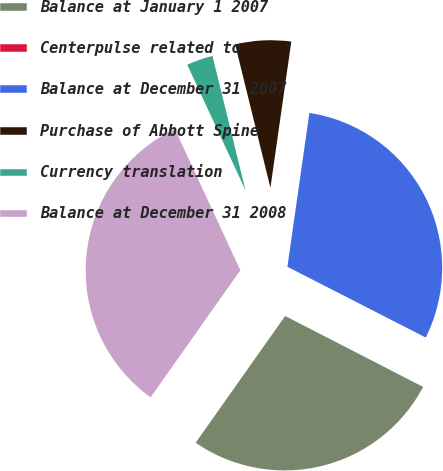Convert chart to OTSL. <chart><loc_0><loc_0><loc_500><loc_500><pie_chart><fcel>Balance at January 1 2007<fcel>Centerpulse related to<fcel>Balance at December 31 2007<fcel>Purchase of Abbott Spine<fcel>Currency translation<fcel>Balance at December 31 2008<nl><fcel>27.23%<fcel>0.03%<fcel>30.27%<fcel>6.1%<fcel>3.07%<fcel>33.31%<nl></chart> 